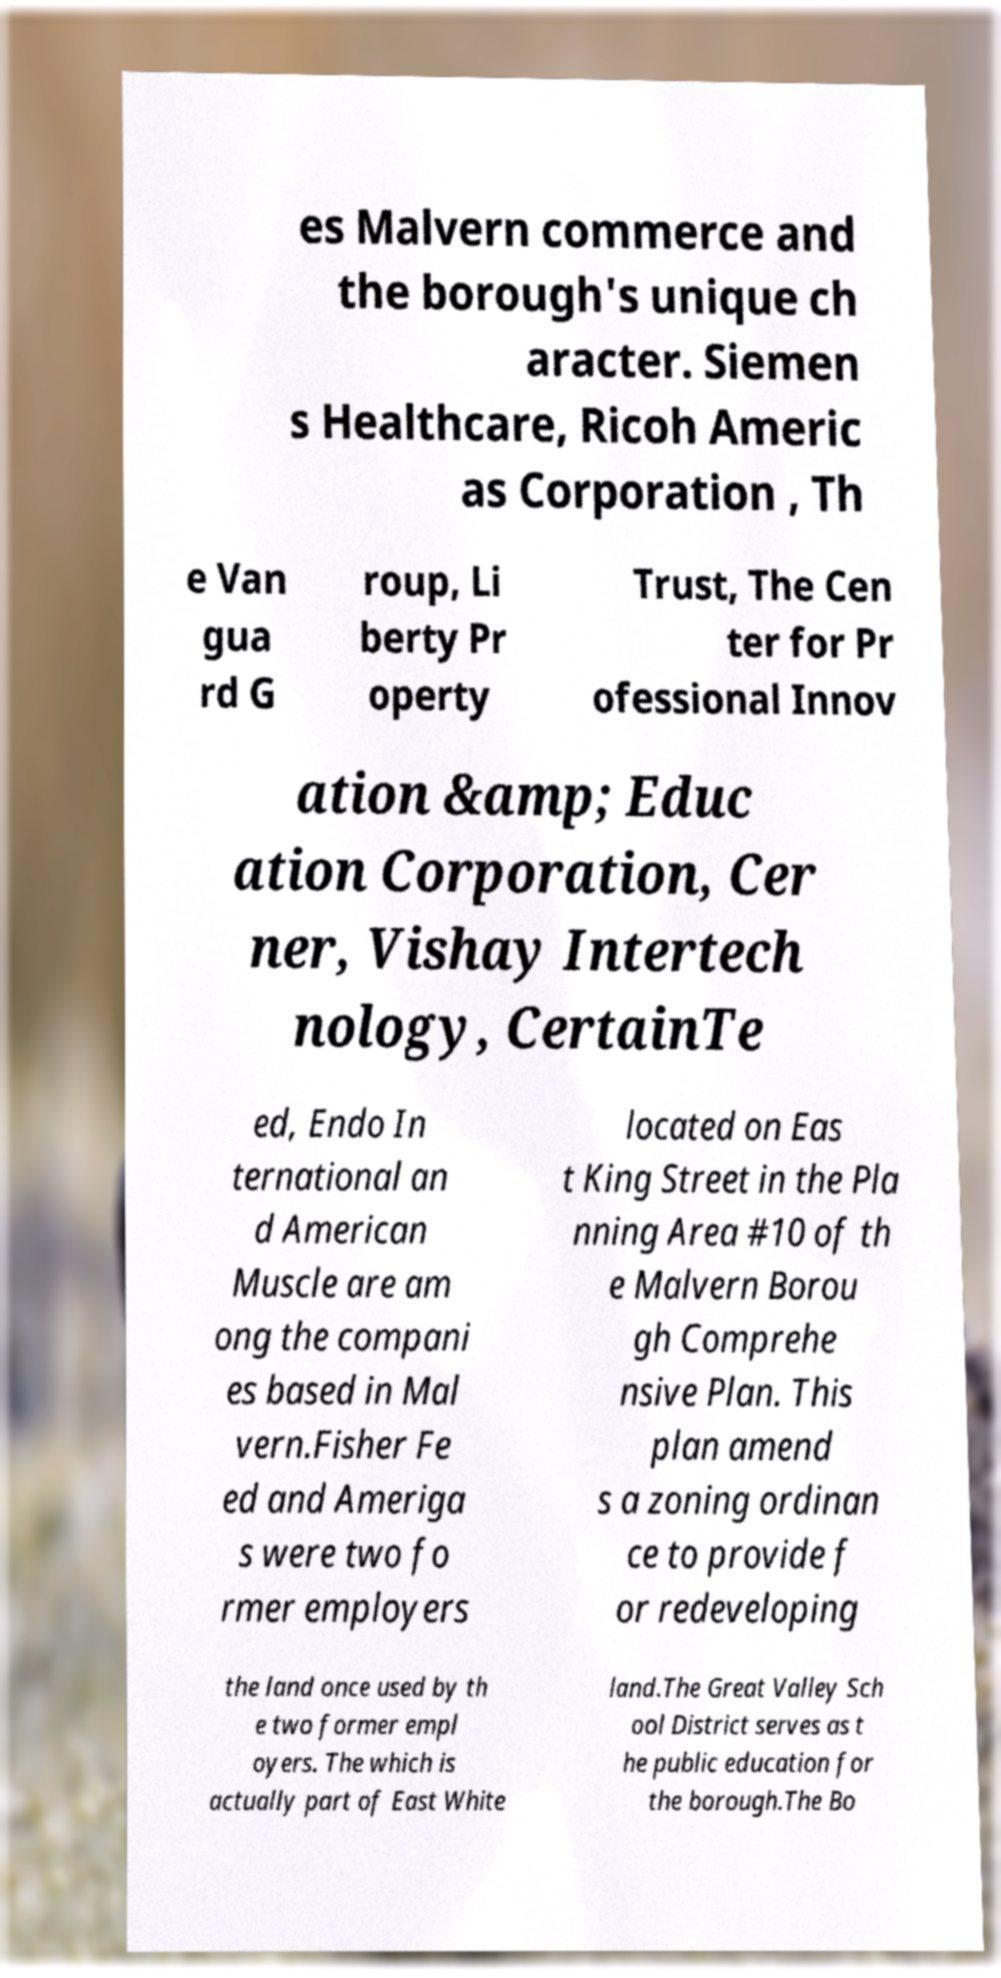Please read and relay the text visible in this image. What does it say? es Malvern commerce and the borough's unique ch aracter. Siemen s Healthcare, Ricoh Americ as Corporation , Th e Van gua rd G roup, Li berty Pr operty Trust, The Cen ter for Pr ofessional Innov ation &amp; Educ ation Corporation, Cer ner, Vishay Intertech nology, CertainTe ed, Endo In ternational an d American Muscle are am ong the compani es based in Mal vern.Fisher Fe ed and Ameriga s were two fo rmer employers located on Eas t King Street in the Pla nning Area #10 of th e Malvern Borou gh Comprehe nsive Plan. This plan amend s a zoning ordinan ce to provide f or redeveloping the land once used by th e two former empl oyers. The which is actually part of East White land.The Great Valley Sch ool District serves as t he public education for the borough.The Bo 